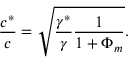<formula> <loc_0><loc_0><loc_500><loc_500>\frac { c ^ { * } } { c } = \sqrt { \frac { \gamma ^ { * } } { \gamma } \frac { 1 } { 1 + \Phi _ { m } } } .</formula> 